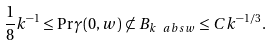Convert formula to latex. <formula><loc_0><loc_0><loc_500><loc_500>\frac { 1 } { 8 } k ^ { - 1 } \leq \Pr { \gamma ( 0 , w ) \not \subset B _ { k \ a b s { w } } } \leq C k ^ { - 1 / 3 } .</formula> 